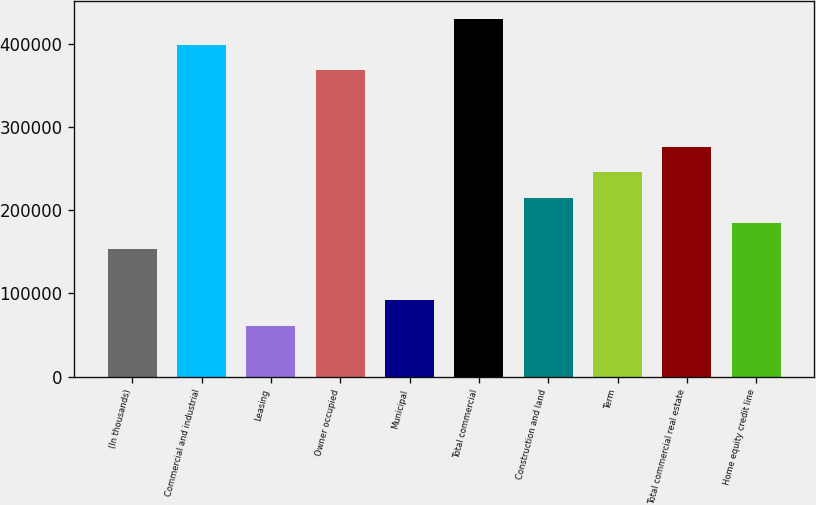Convert chart to OTSL. <chart><loc_0><loc_0><loc_500><loc_500><bar_chart><fcel>(In thousands)<fcel>Commercial and industrial<fcel>Leasing<fcel>Owner occupied<fcel>Municipal<fcel>Total commercial<fcel>Construction and land<fcel>Term<fcel>Total commercial real estate<fcel>Home equity credit line<nl><fcel>153422<fcel>398584<fcel>61486.4<fcel>367938<fcel>92131.6<fcel>429229<fcel>214712<fcel>245358<fcel>276003<fcel>184067<nl></chart> 